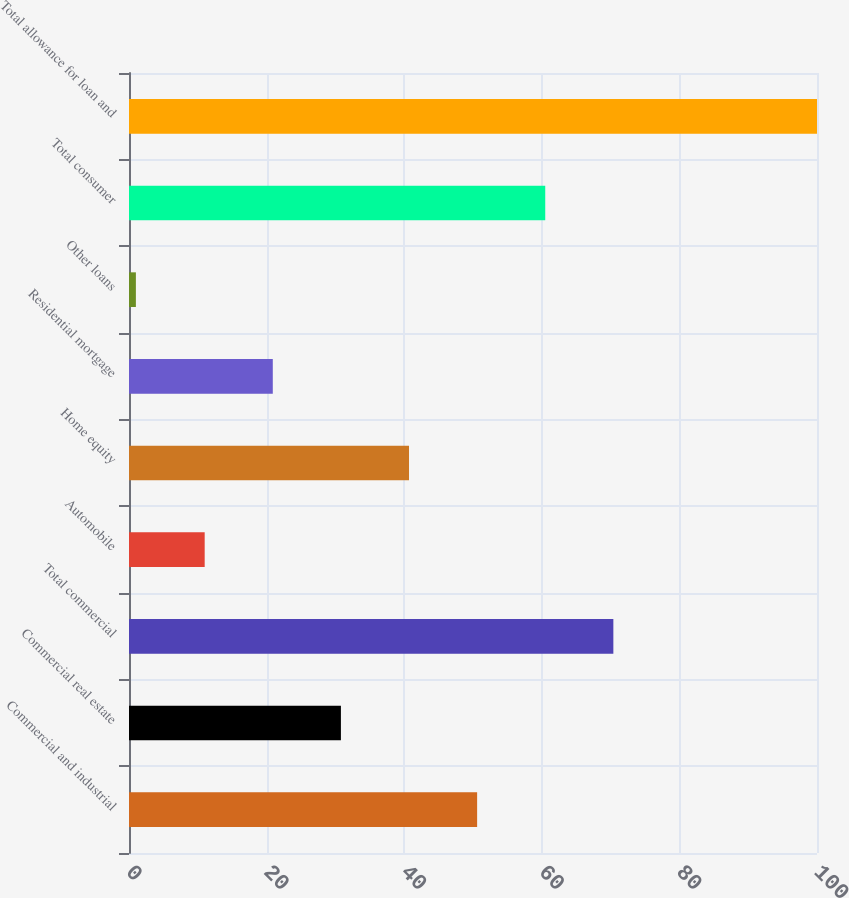Convert chart to OTSL. <chart><loc_0><loc_0><loc_500><loc_500><bar_chart><fcel>Commercial and industrial<fcel>Commercial real estate<fcel>Total commercial<fcel>Automobile<fcel>Home equity<fcel>Residential mortgage<fcel>Other loans<fcel>Total consumer<fcel>Total allowance for loan and<nl><fcel>50.6<fcel>30.8<fcel>70.4<fcel>11<fcel>40.7<fcel>20.9<fcel>1<fcel>60.5<fcel>100<nl></chart> 